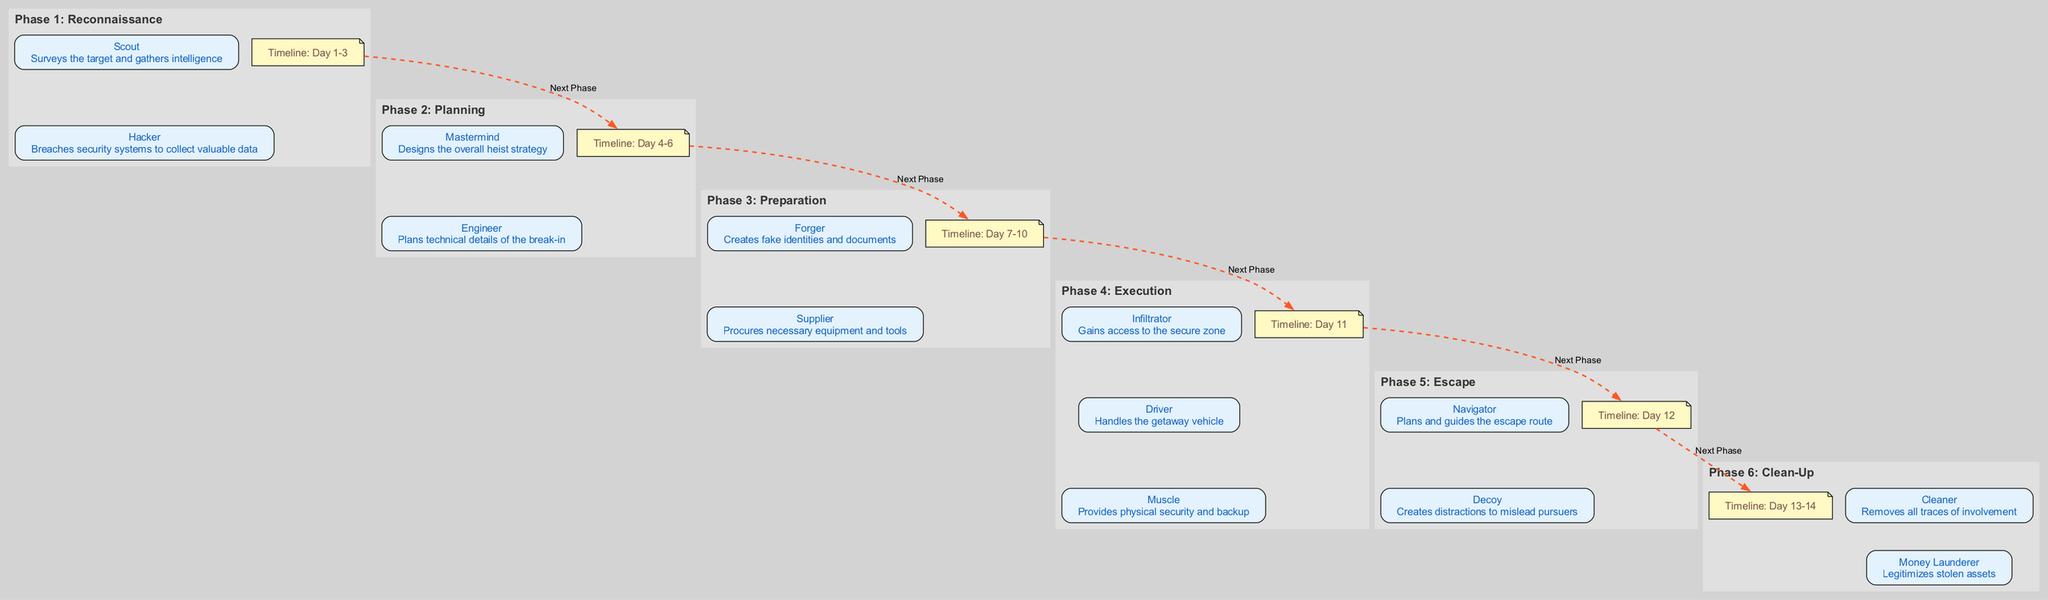What is the duration of the "Execution" phase? The "Execution" phase is displayed in the timeline node with the value "Day 11". Therefore, it lasts for one day.
Answer: Day 11 How many roles are involved in the "Planning" phase? The "Planning" phase has two roles listed: "Mastermind" and "Engineer". Therefore, the total number of roles is 2.
Answer: 2 What role is responsible for removing traces of involvement? In the "Clean-Up" phase, the role that is described as responsible for removing all traces of involvement is the "Cleaner".
Answer: Cleaner What phase follows "Preparation"? The diagram has a dashed edge indicating the flow from the "Preparation" phase to the next phase. The next phase after "Preparation" is labeled as "Execution".
Answer: Execution Who is responsible for creating fake identities in the "Preparation" phase? In the "Preparation" phase, the role specifically tasked with creating fake identities and documents is the "Forger".
Answer: Forger Which role in the "Execution" phase handles the getaway vehicle? The "Driver" role is responsible for handling the getaway vehicle during the "Execution" phase, as indicated in the diagram under that phase.
Answer: Driver What is the total number of phases depicted in the diagram? By counting each phase from 1 to 6 as represented in the diagram, there are a total of 6 phases described within it.
Answer: 6 What is the main role of the "Mastermind"? The diagram states that the "Mastermind" designs the overall heist strategy in the "Planning" phase.
Answer: Designs the overall heist strategy What happens immediately after the "Escape" phase? The last phase mentioned in the diagram is "Clean-Up", which follows the "Escape" phase. Therefore, nothing happens after "Clean-Up" as it's the final phase.
Answer: (Nothing) 